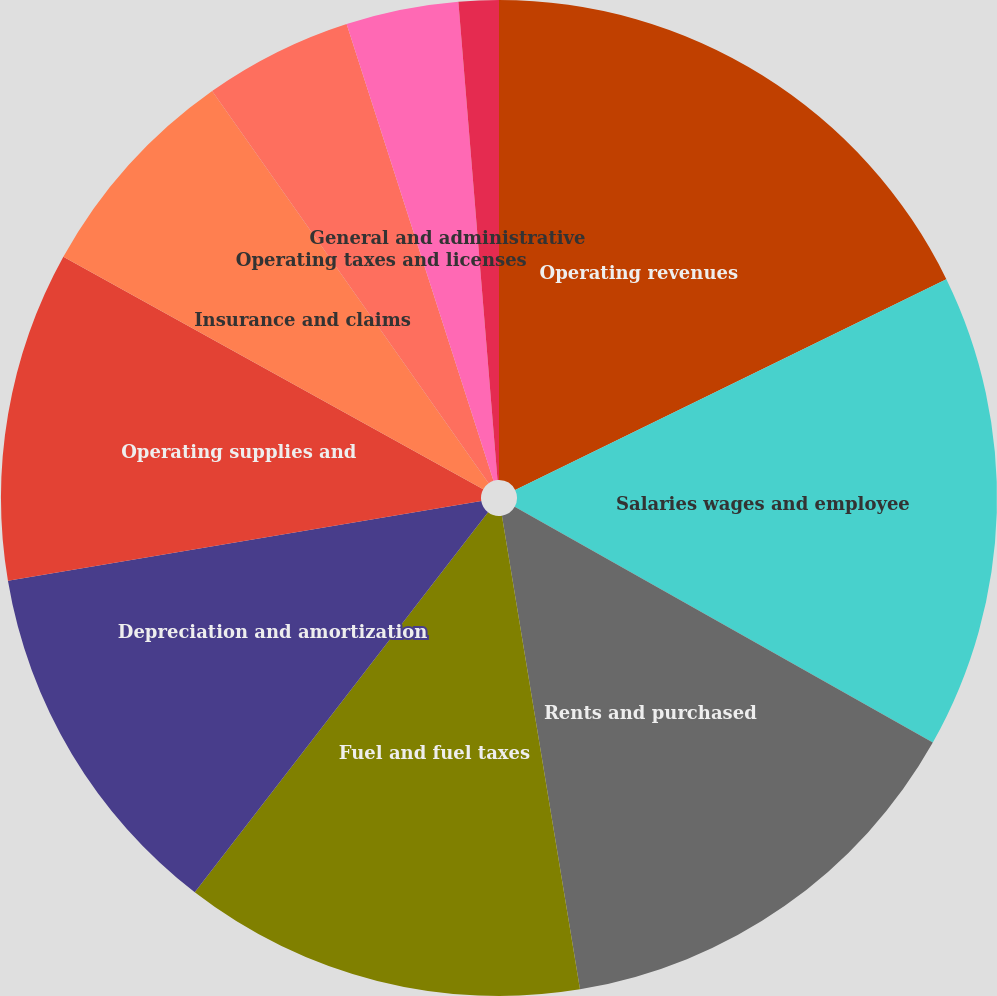Convert chart. <chart><loc_0><loc_0><loc_500><loc_500><pie_chart><fcel>Operating revenues<fcel>Salaries wages and employee<fcel>Rents and purchased<fcel>Fuel and fuel taxes<fcel>Depreciation and amortization<fcel>Operating supplies and<fcel>Insurance and claims<fcel>Operating taxes and licenses<fcel>General and administrative<fcel>Communication and utilities<nl><fcel>17.76%<fcel>15.41%<fcel>14.23%<fcel>13.06%<fcel>11.88%<fcel>10.71%<fcel>7.18%<fcel>4.82%<fcel>3.65%<fcel>1.3%<nl></chart> 